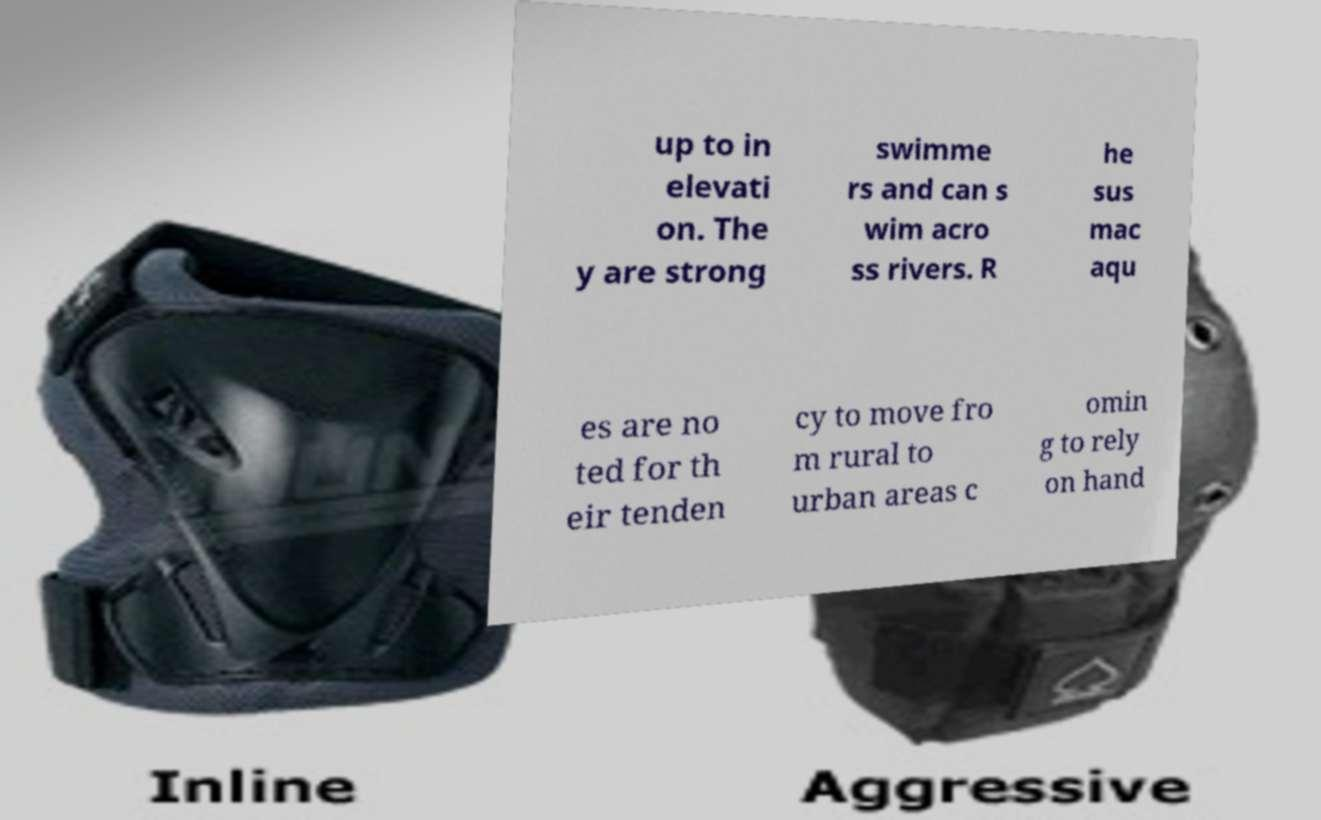Could you assist in decoding the text presented in this image and type it out clearly? up to in elevati on. The y are strong swimme rs and can s wim acro ss rivers. R he sus mac aqu es are no ted for th eir tenden cy to move fro m rural to urban areas c omin g to rely on hand 